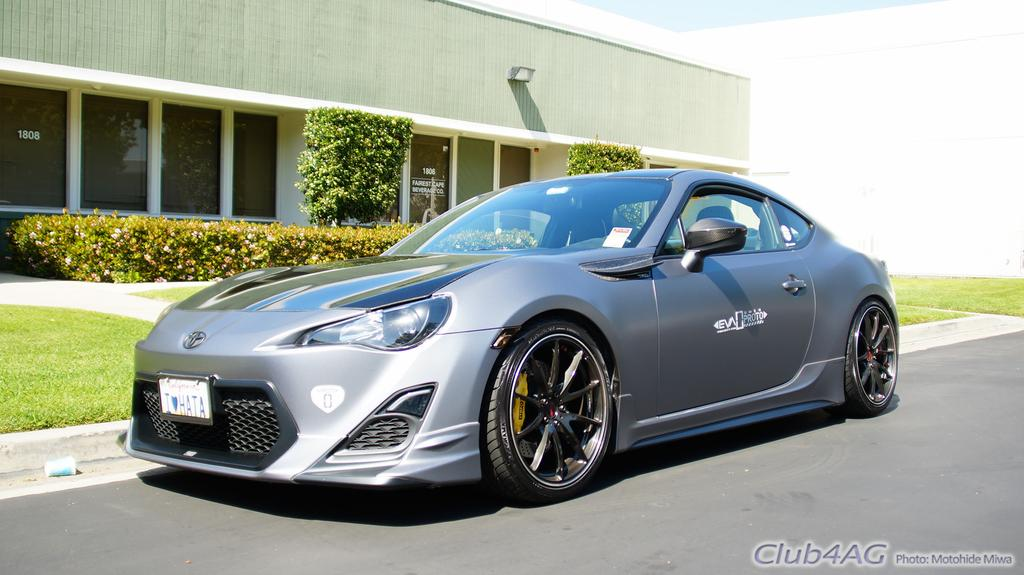What is the main subject of the image? There is a car in the center of the image. Where is the car located? on the image? What can be seen in the background of the image? Buildings, trees, plants, grass, and the sky are visible in the background of the image. Can you describe the setting of the image? The image shows a car on the road, with buildings, trees, plants, grass, and the sky in the background. What type of fiction is the car reading in the image? There is no indication in the image that the car is reading any fiction, as cars do not have the ability to read. 